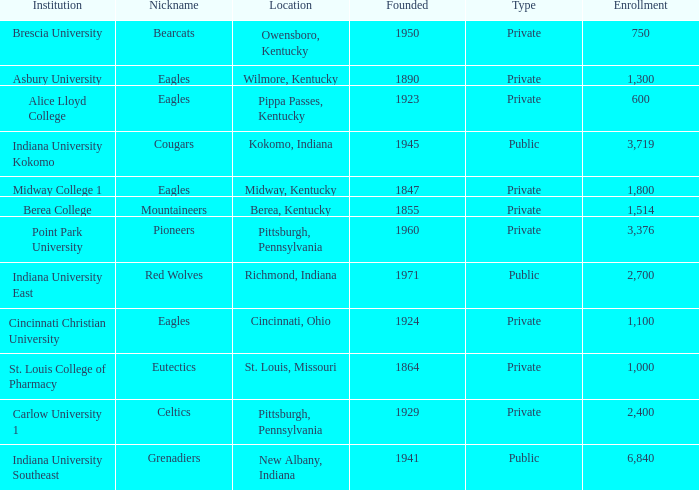Which college's enrollment is less than 1,000? Alice Lloyd College, Brescia University. 